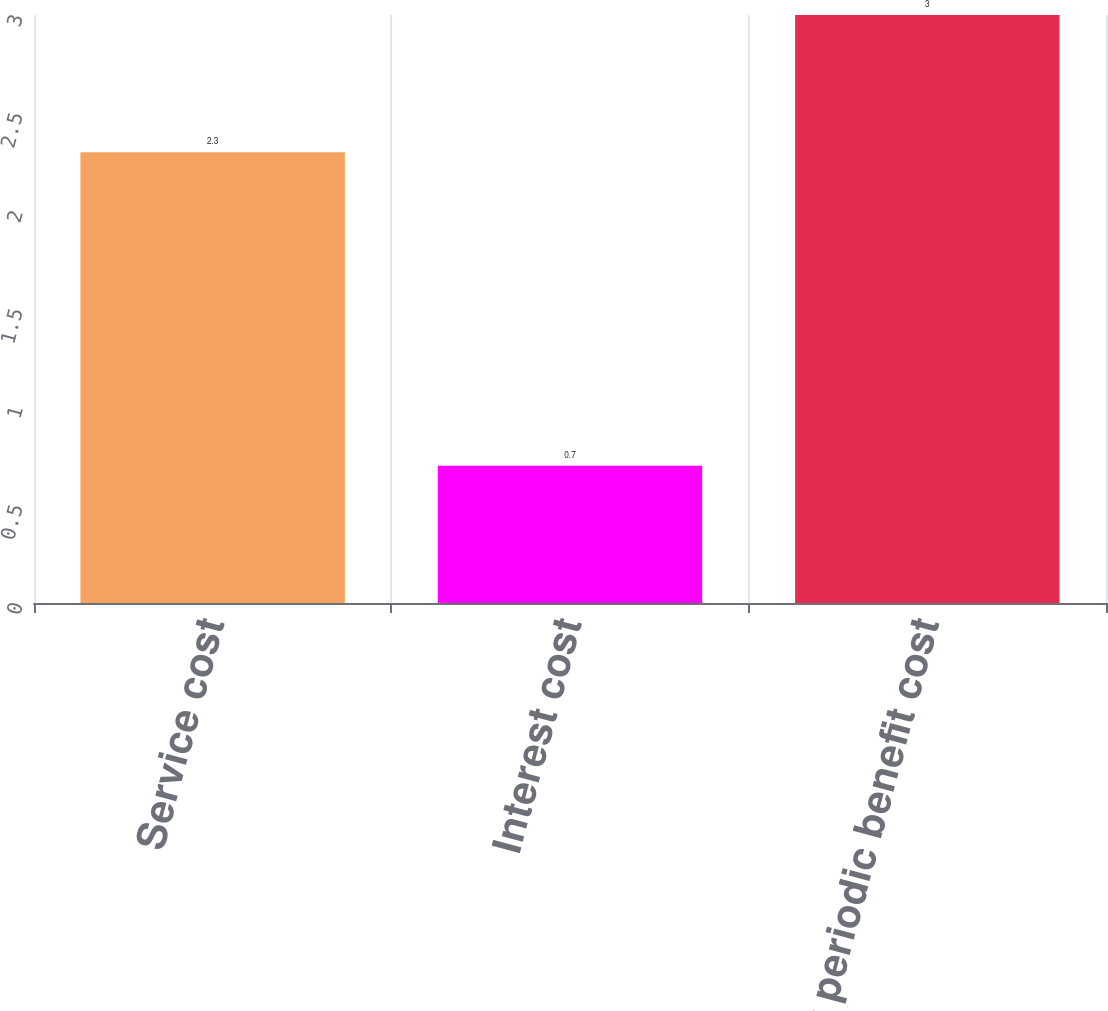<chart> <loc_0><loc_0><loc_500><loc_500><bar_chart><fcel>Service cost<fcel>Interest cost<fcel>Net periodic benefit cost<nl><fcel>2.3<fcel>0.7<fcel>3<nl></chart> 